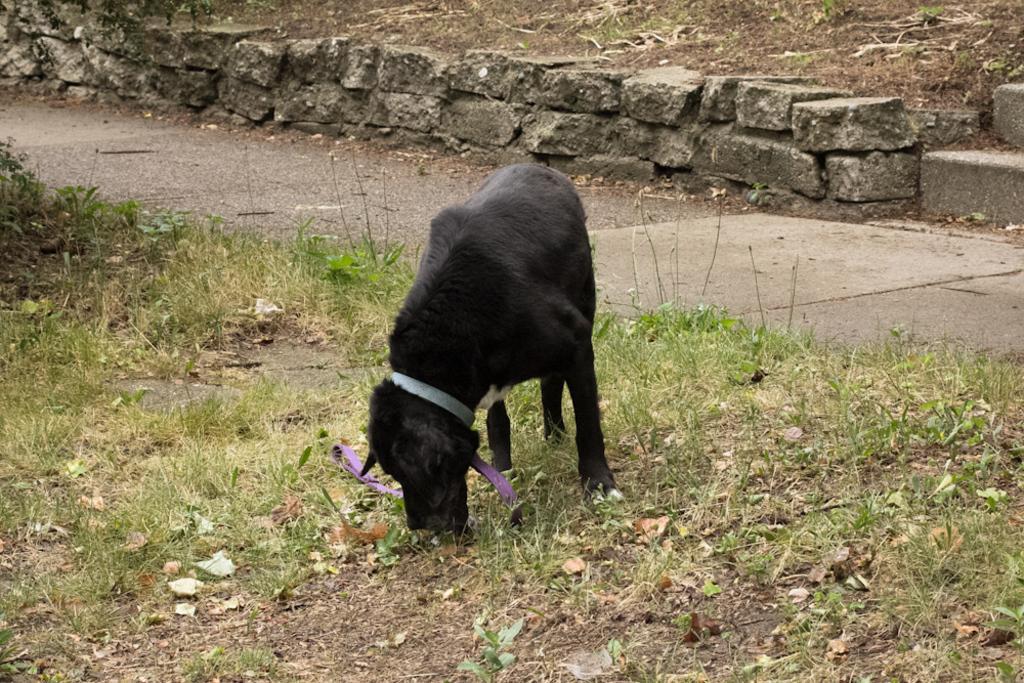Please provide a concise description of this image. In this image we can see a dog standing on the grass. Behind the dog there is a walkway. At the top of the image there are rocks, sand and grass. 